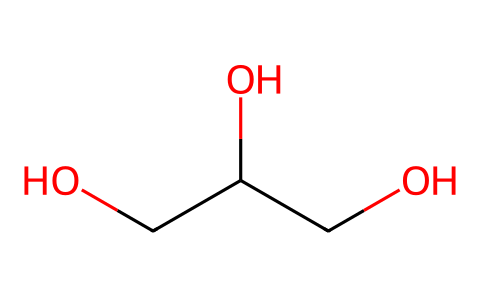How many carbon atoms are in this chemical? The provided SMILES representation shows the chemical structure, where 'C' represents carbon atoms. By counting all instances of 'C', we can identify the number of carbon atoms. In this case, we find four carbon atoms.
Answer: 4 What is the functional group present in this compound? The structure of the chemical indicates the presence of hydroxyl groups (-OH), specifically seen in the parts of the structure denoted by 'O' that are directly attached to carbon atoms. This signifies that the functional group is an alcohol.
Answer: alcohol What is the total number of oxygen atoms in this chemical? By inspecting the SMILES, we count the instances of 'O', which indicates the oxygen atoms present in the structure. There are three 'O's, meaning the compound contains three oxygen atoms.
Answer: 3 Does this compound show characteristics of a coordination compound? Coordination compounds often involve transition metals coordinating with ligands. This chemical lacks a metal center and instead has only carbon, hydrogen, and oxygen, indicating it is not a coordination compound.
Answer: no What type of interaction could this compound facilitate with vocal cords? The presence of hydroxyl functional groups allows for hydrogen bonding, which can contribute to lubrication and moisture retention, facilitating a smoother interaction with vocal cords.
Answer: lubrication Is this compound likely polar or non-polar? The presence of hydroxyl groups suggests that this compound has polar characteristics due to the electronegative oxygen atoms attracting electrons more than carbon or hydrogen, making it hydrophilic.
Answer: polar 